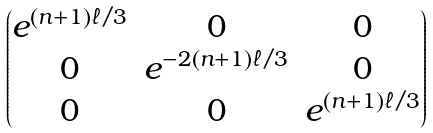Convert formula to latex. <formula><loc_0><loc_0><loc_500><loc_500>\begin{pmatrix} e ^ { ( n + 1 ) \ell / 3 } & 0 & 0 \\ 0 & e ^ { - 2 ( n + 1 ) \ell / 3 } & 0 \\ 0 & 0 & e ^ { ( n + 1 ) \ell / 3 } \end{pmatrix}</formula> 